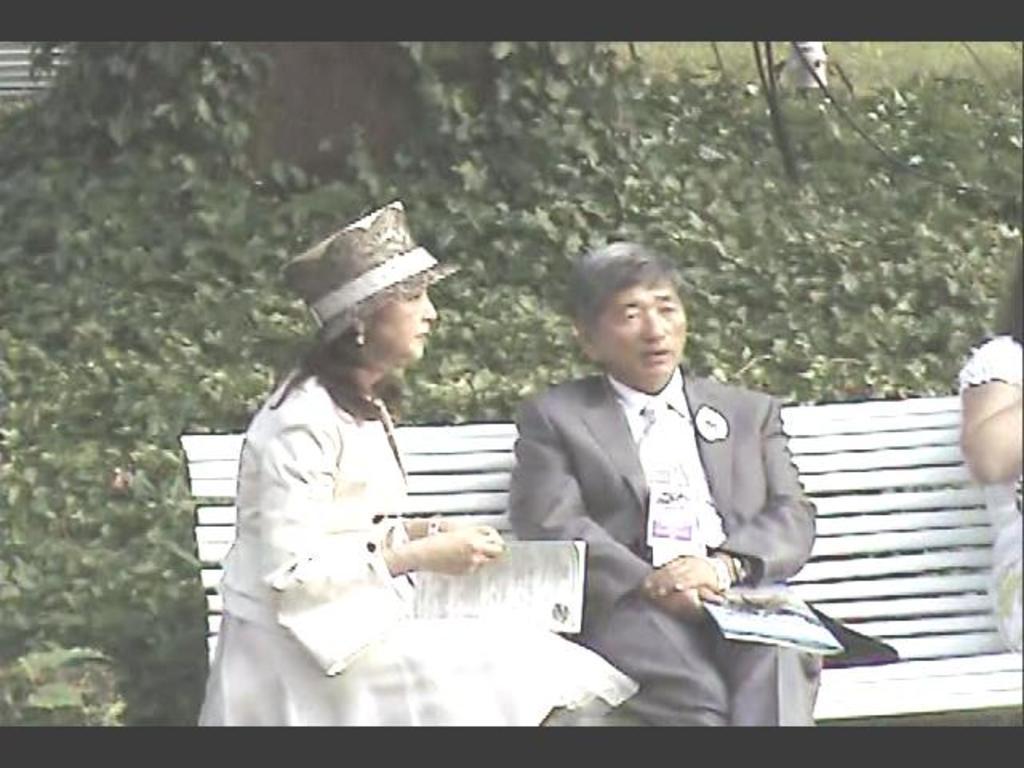Can you describe this image briefly? In this image in the middle there is a man, he wears a suit, shirt, trouser, he is holding a book, he is sitting. On the left there is a woman, she wears a dress, that, she is sitting, she is holding a book. On the right there is a woman, they are sitting on the bench. In the background there are plants, trees. 